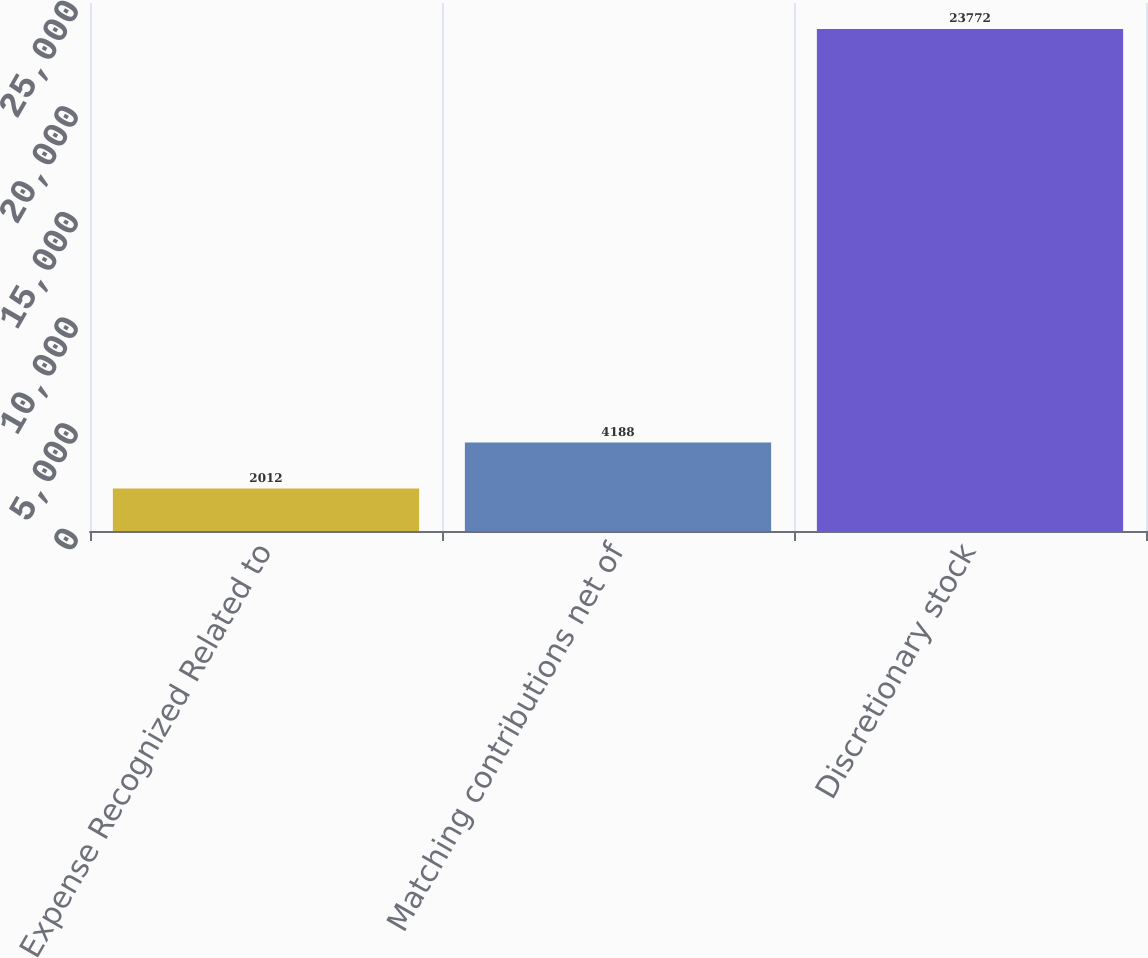<chart> <loc_0><loc_0><loc_500><loc_500><bar_chart><fcel>Expense Recognized Related to<fcel>Matching contributions net of<fcel>Discretionary stock<nl><fcel>2012<fcel>4188<fcel>23772<nl></chart> 